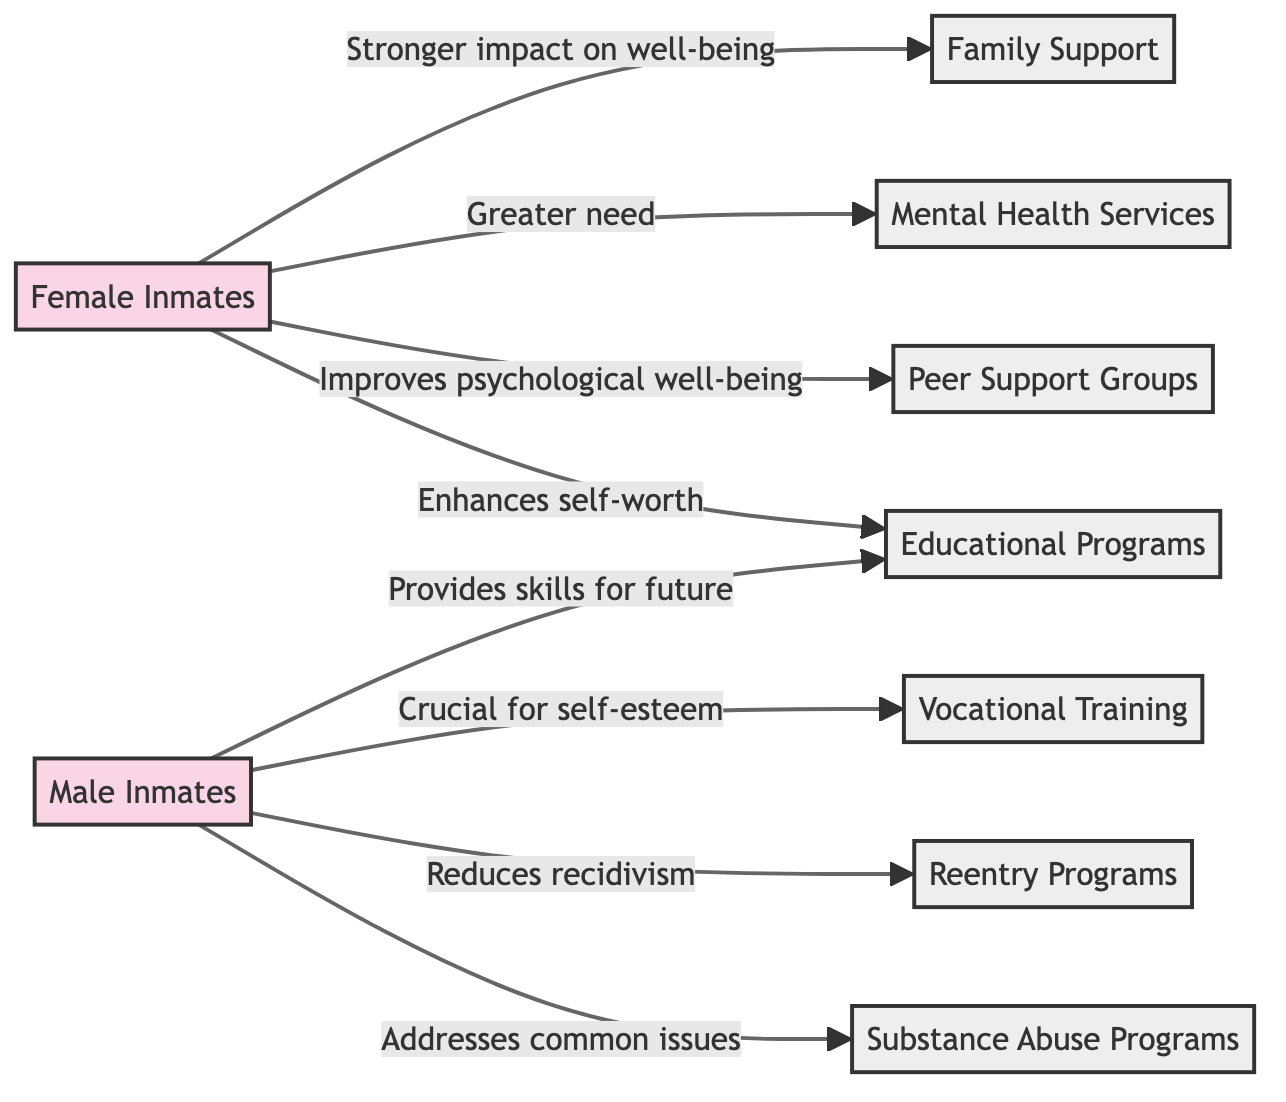What are the types of inmates represented in the diagram? The diagram includes "Female Inmates" and "Male Inmates" as the two types of inmates represented.
Answer: Female Inmates, Male Inmates Which support system is linked to female inmates that emphasizes the need for mental health services? The diagram indicates that "Mental Health Services" is linked to "Female Inmates", highlighting a greater need for these services among them.
Answer: Mental Health Services How many support systems are linked to male inmates? The diagram shows four support systems linked to "Male Inmates", which are "Vocational Training", "Reentry Programs", "Substance Abuse Programs", and "Educational Programs".
Answer: 4 What is the relationship between female inmates and peer support groups? The diagram states that peer support groups can "improve psychological well-being" for female inmates, indicating a positive effect.
Answer: Improves psychological well-being How does family support impact the well-being of female inmates? The diagram describes that family support may have a "stronger impact on well-being" for female inmates, indicating its significance in their mental health.
Answer: Stronger impact on well-being Which support system linked to male inmates specifically addresses a common issue affecting their mental health? The "Substance Abuse Programs" are explicitly noted in the diagram as addressing a common issue for male inmates.
Answer: Substance Abuse Programs What is the specific connection between male inmates and vocational training? The diagram indicates that vocational training programs are "crucial for self-esteem and reintegration" for male inmates, emphasizing its importance.
Answer: Crucial for self-esteem How many nodes represent support systems in total? There are six support systems represented in the diagram, which include family support, mental health services, vocational training, reentry programs, peer support groups, substance abuse programs, and educational programs.
Answer: 6 What type of relationship connects male inmates and reentry programs? The relationship described in the diagram indicates that the reentry programs "reduce recidivism" and support psychological well-being for male inmates, highlighting its critical role.
Answer: Reduces recidivism Which support system is linked to both female and male inmates? The "Educational Programs" are linked to both female and male inmates, with a focus on enhancing self-worth for females and providing skills for better opportunities for males.
Answer: Educational Programs 